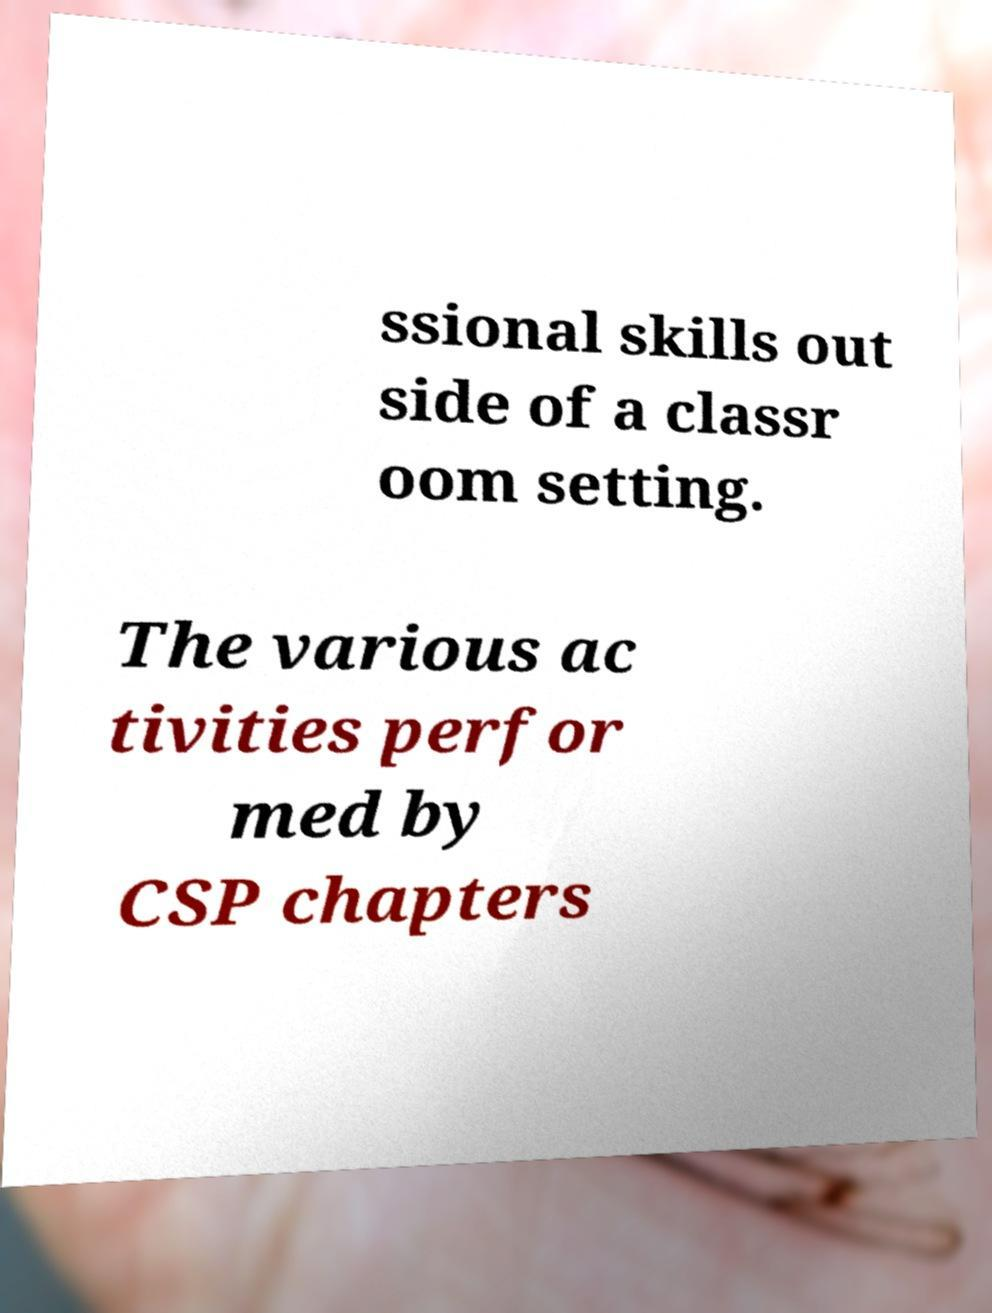Please identify and transcribe the text found in this image. ssional skills out side of a classr oom setting. The various ac tivities perfor med by CSP chapters 